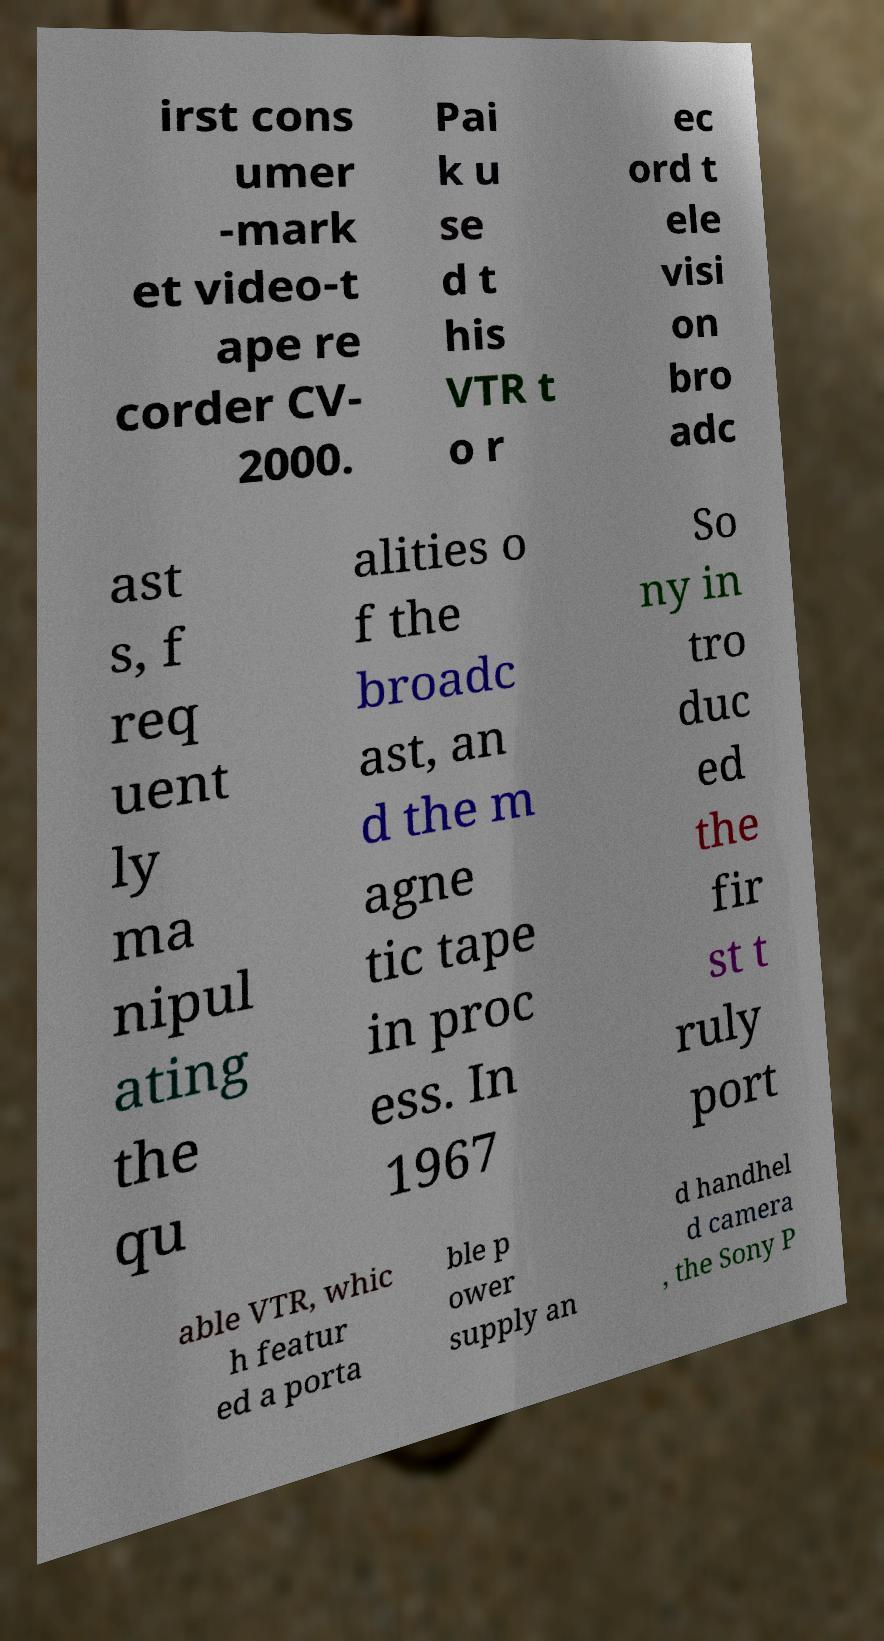Please read and relay the text visible in this image. What does it say? irst cons umer -mark et video-t ape re corder CV- 2000. Pai k u se d t his VTR t o r ec ord t ele visi on bro adc ast s, f req uent ly ma nipul ating the qu alities o f the broadc ast, an d the m agne tic tape in proc ess. In 1967 So ny in tro duc ed the fir st t ruly port able VTR, whic h featur ed a porta ble p ower supply an d handhel d camera , the Sony P 